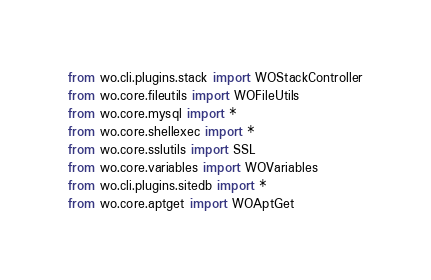Convert code to text. <code><loc_0><loc_0><loc_500><loc_500><_Python_>from wo.cli.plugins.stack import WOStackController
from wo.core.fileutils import WOFileUtils
from wo.core.mysql import *
from wo.core.shellexec import *
from wo.core.sslutils import SSL
from wo.core.variables import WOVariables
from wo.cli.plugins.sitedb import *
from wo.core.aptget import WOAptGet</code> 